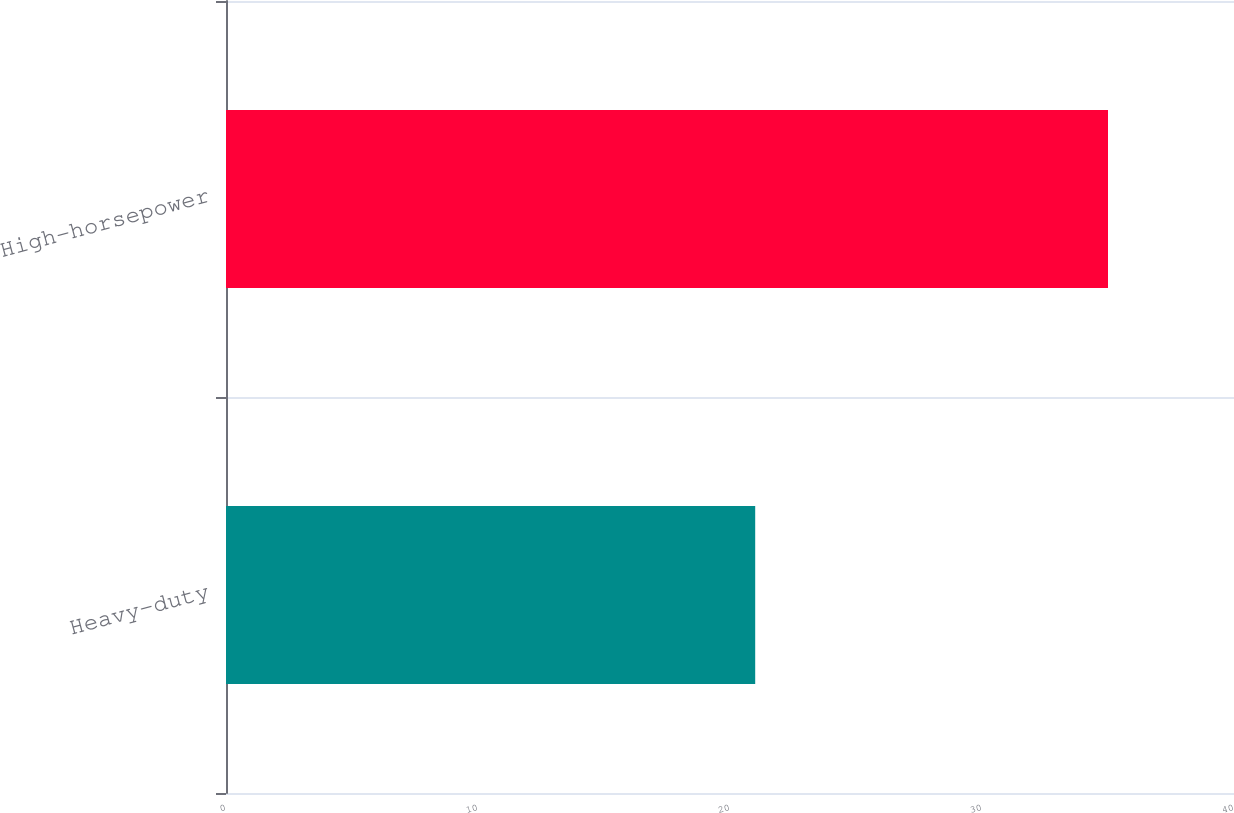<chart> <loc_0><loc_0><loc_500><loc_500><bar_chart><fcel>Heavy-duty<fcel>High-horsepower<nl><fcel>21<fcel>35<nl></chart> 